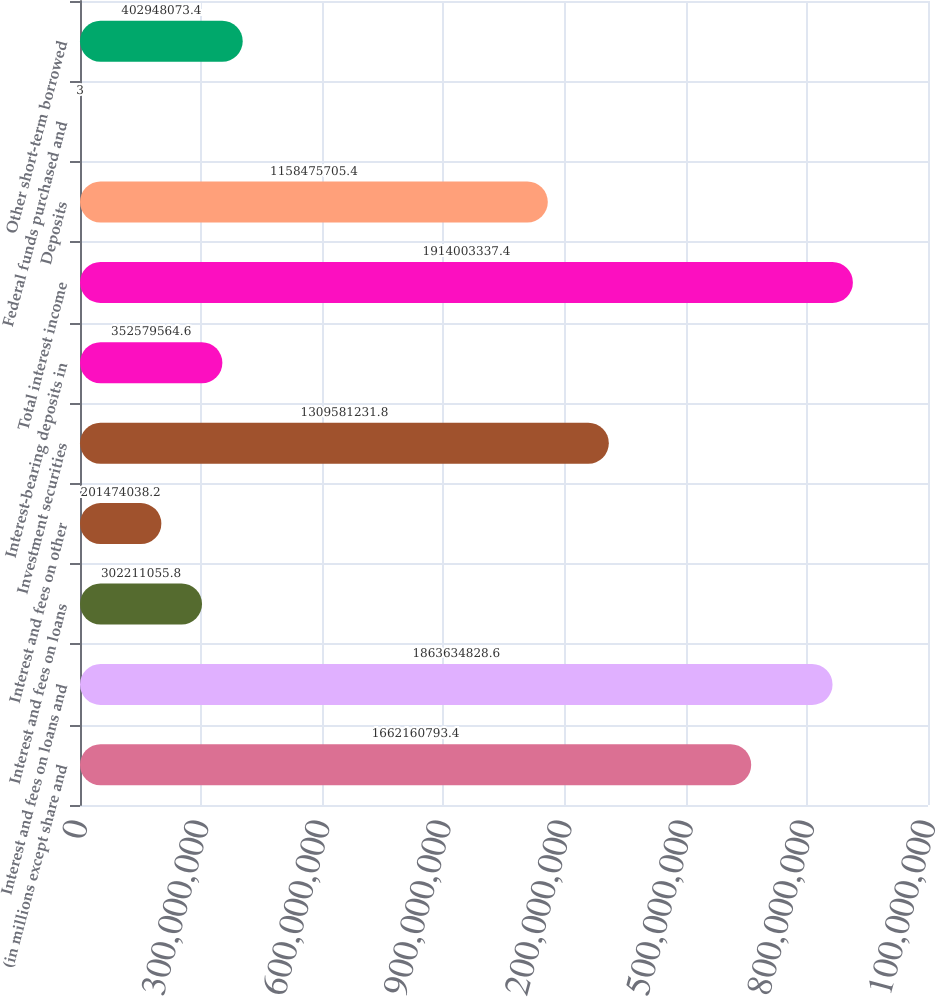Convert chart to OTSL. <chart><loc_0><loc_0><loc_500><loc_500><bar_chart><fcel>(in millions except share and<fcel>Interest and fees on loans and<fcel>Interest and fees on loans<fcel>Interest and fees on other<fcel>Investment securities<fcel>Interest-bearing deposits in<fcel>Total interest income<fcel>Deposits<fcel>Federal funds purchased and<fcel>Other short-term borrowed<nl><fcel>1.66216e+09<fcel>1.86363e+09<fcel>3.02211e+08<fcel>2.01474e+08<fcel>1.30958e+09<fcel>3.5258e+08<fcel>1.914e+09<fcel>1.15848e+09<fcel>3<fcel>4.02948e+08<nl></chart> 